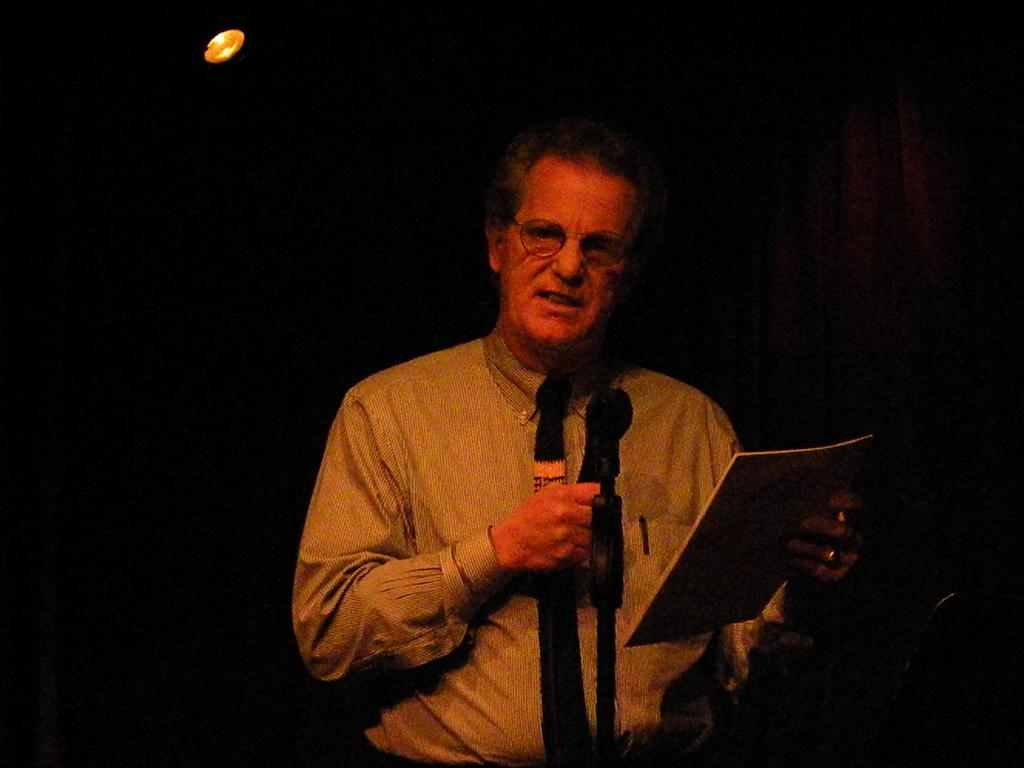What is the man in the image doing with his right hand? The man is holding a microphone in his right hand. What is the man doing while holding the microphone? The man is speaking. What is the man holding in his left hand? The man is holding a book in his left hand. Can you describe the lighting in the image? There is a light visible in the image. Where is the playground located in the image? There is no playground present in the image. What type of hammer is the man using in the image? There is no hammer present in the image. 